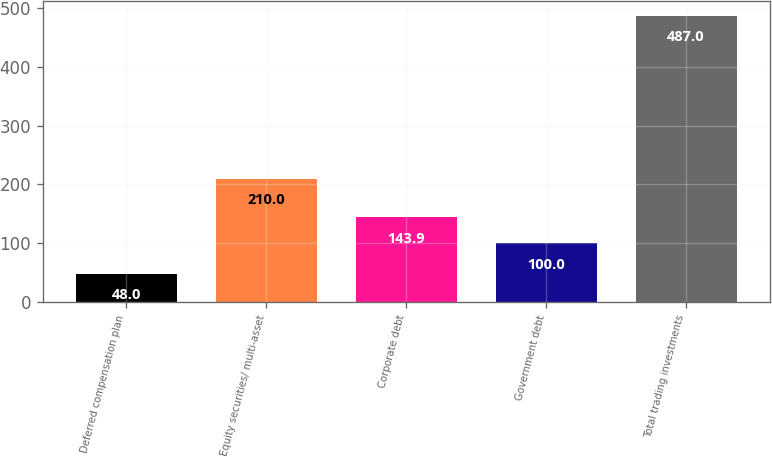<chart> <loc_0><loc_0><loc_500><loc_500><bar_chart><fcel>Deferred compensation plan<fcel>Equity securities/ multi-asset<fcel>Corporate debt<fcel>Government debt<fcel>Total trading investments<nl><fcel>48<fcel>210<fcel>143.9<fcel>100<fcel>487<nl></chart> 